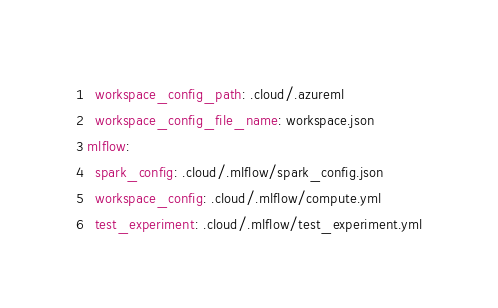Convert code to text. <code><loc_0><loc_0><loc_500><loc_500><_YAML_>  workspace_config_path: .cloud/.azureml
  workspace_config_file_name: workspace.json
mlflow:
  spark_config: .cloud/.mlflow/spark_config.json
  workspace_config: .cloud/.mlflow/compute.yml
  test_experiment: .cloud/.mlflow/test_experiment.yml</code> 